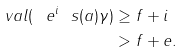Convert formula to latex. <formula><loc_0><loc_0><loc_500><loc_500>\ v a l ( \ e ^ { i } \ s ( a ) \gamma ) & \geq f + i \\ & > f + e .</formula> 